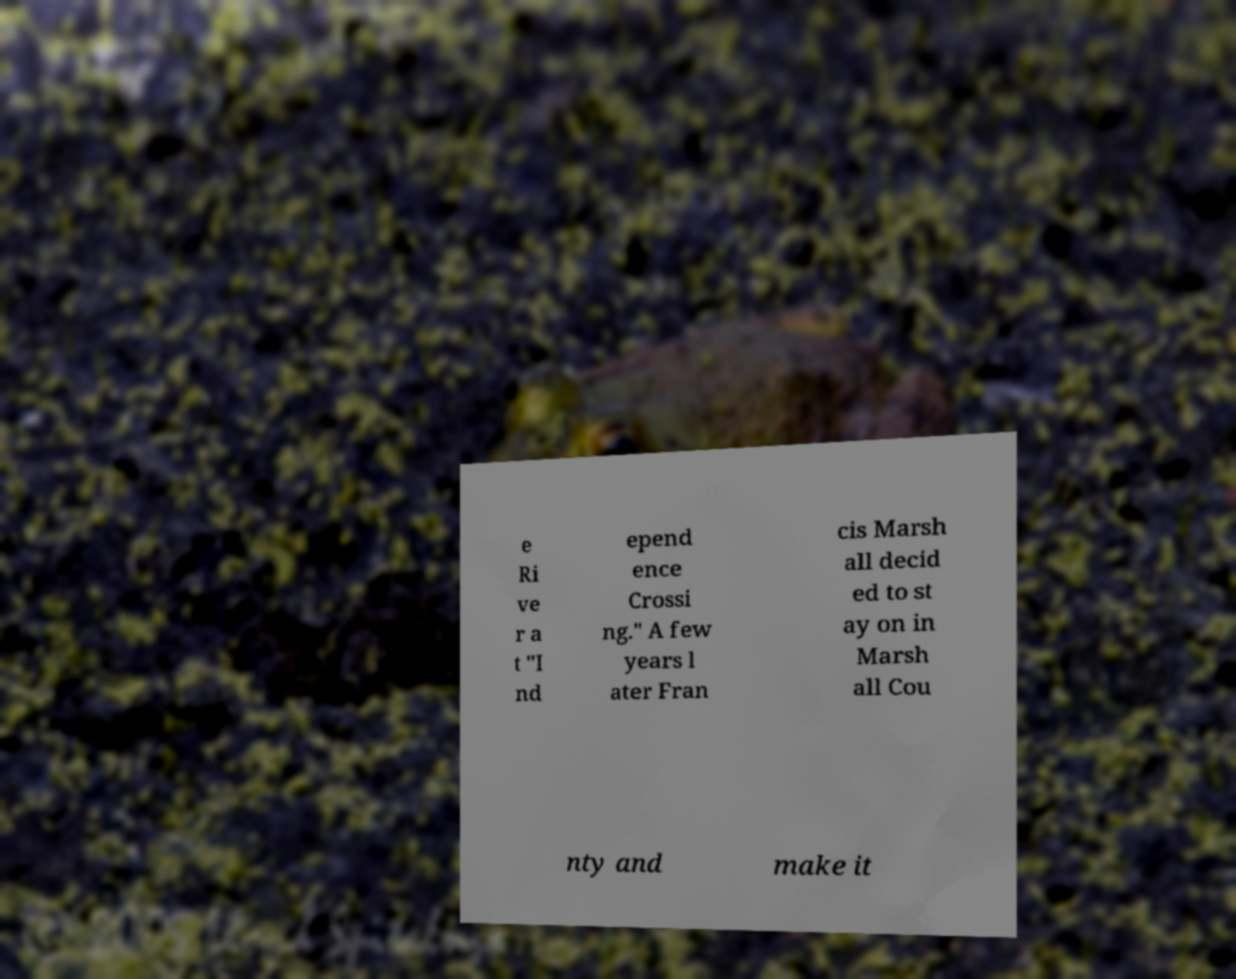Could you assist in decoding the text presented in this image and type it out clearly? e Ri ve r a t "I nd epend ence Crossi ng." A few years l ater Fran cis Marsh all decid ed to st ay on in Marsh all Cou nty and make it 